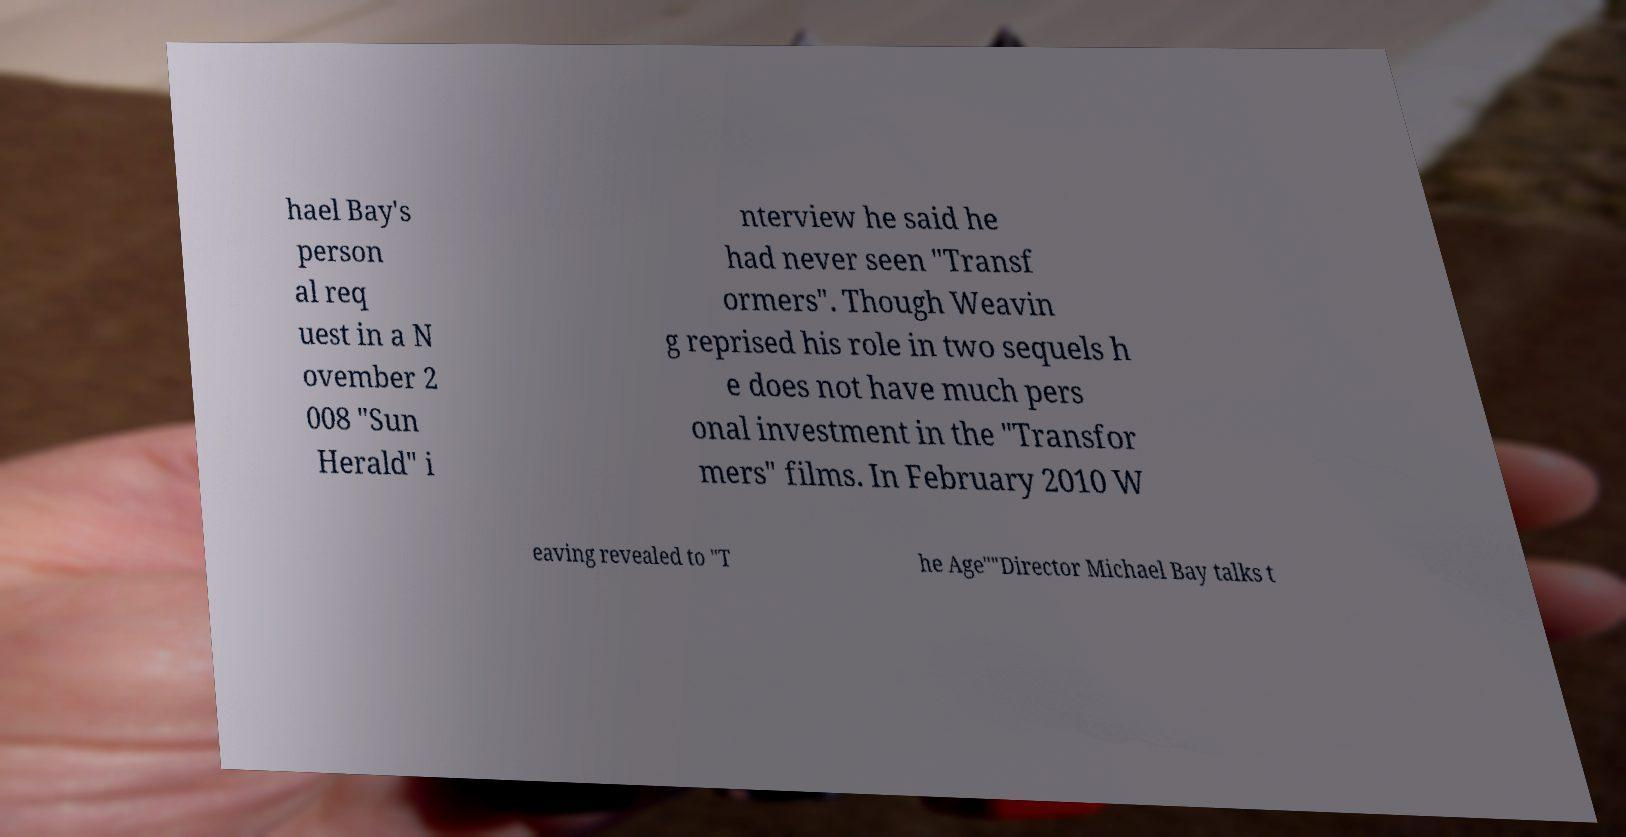Could you assist in decoding the text presented in this image and type it out clearly? hael Bay's person al req uest in a N ovember 2 008 "Sun Herald" i nterview he said he had never seen "Transf ormers". Though Weavin g reprised his role in two sequels h e does not have much pers onal investment in the "Transfor mers" films. In February 2010 W eaving revealed to "T he Age""Director Michael Bay talks t 